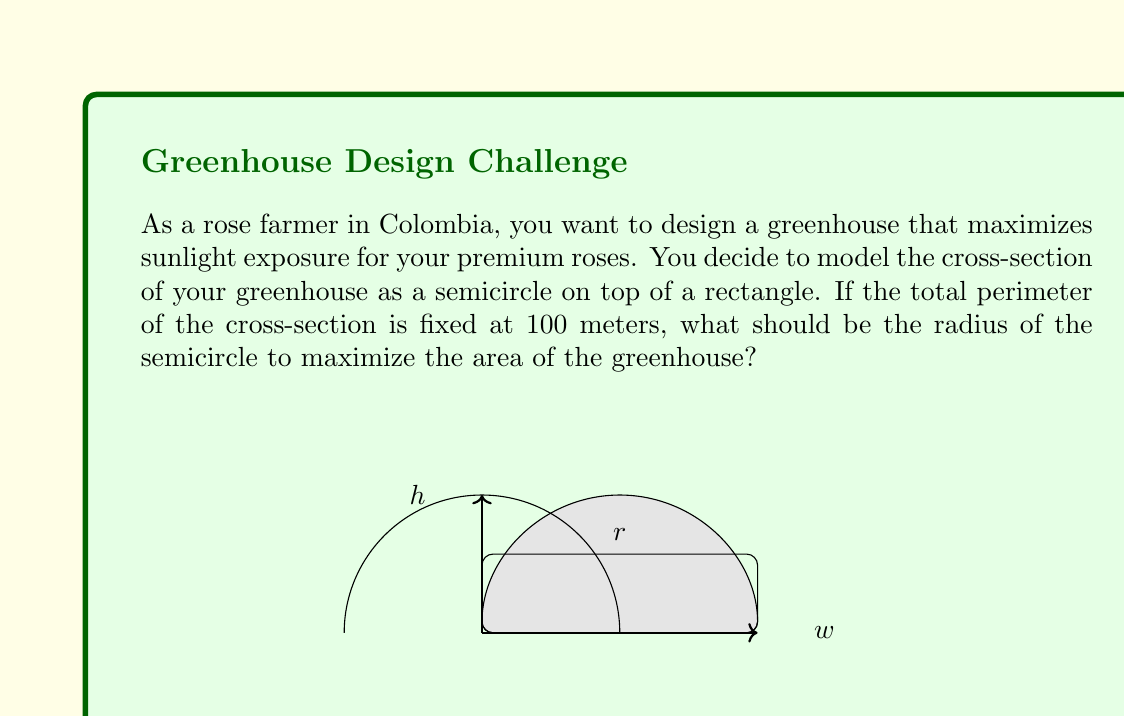Could you help me with this problem? Let's approach this step-by-step:

1) Let $r$ be the radius of the semicircle, $w$ be the width of the rectangle, and $h$ be the height of the rectangle.

2) The perimeter constraint gives us:
   $$\pi r + 2r + 2h + w = 100$$

3) We know that $w = 2r$ (diameter of the semicircle), so we can substitute:
   $$\pi r + 2r + 2h + 2r = 100$$
   $$\pi r + 4r + 2h = 100$$
   $$(\pi + 4)r + 2h = 100$$

4) The area of the greenhouse is:
   $$A = \frac{1}{2}\pi r^2 + 2rh$$

5) We can express $h$ in terms of $r$ using the perimeter equation:
   $$h = \frac{100 - (\pi + 4)r}{2}$$

6) Substituting this into the area equation:
   $$A = \frac{1}{2}\pi r^2 + 2r\left(\frac{100 - (\pi + 4)r}{2}\right)$$
   $$A = \frac{1}{2}\pi r^2 + 100r - (\pi + 4)r^2$$
   $$A = 100r - (\frac{\pi}{2} + 4)r^2$$

7) To maximize this area, we differentiate with respect to $r$ and set it to zero:
   $$\frac{dA}{dr} = 100 - (2\pi + 8)r = 0$$

8) Solving this:
   $$r = \frac{100}{2\pi + 8} \approx 13.45$$

9) We can confirm this is a maximum by checking the second derivative is negative.
Answer: The optimal radius for the semicircle is approximately 13.45 meters. 